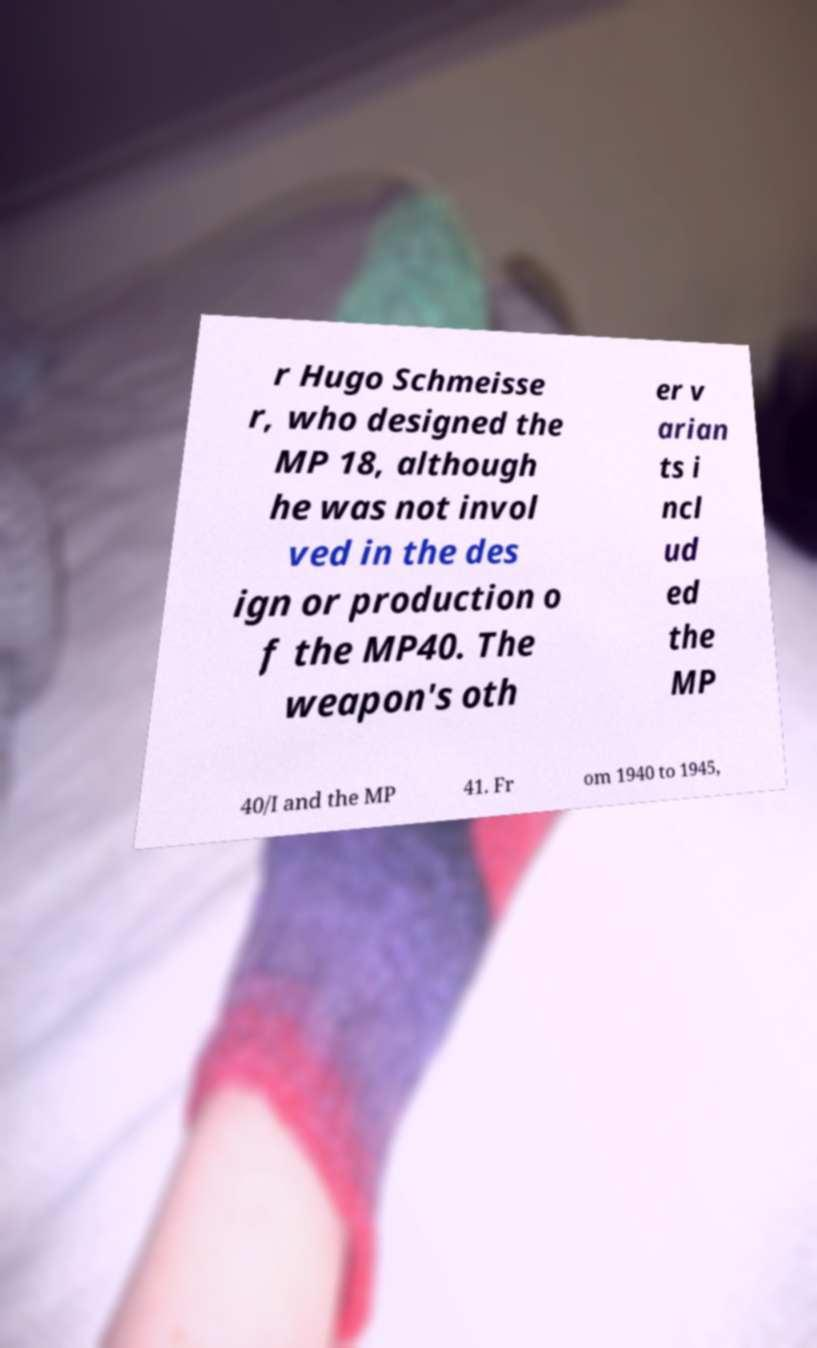Could you extract and type out the text from this image? r Hugo Schmeisse r, who designed the MP 18, although he was not invol ved in the des ign or production o f the MP40. The weapon's oth er v arian ts i ncl ud ed the MP 40/I and the MP 41. Fr om 1940 to 1945, 